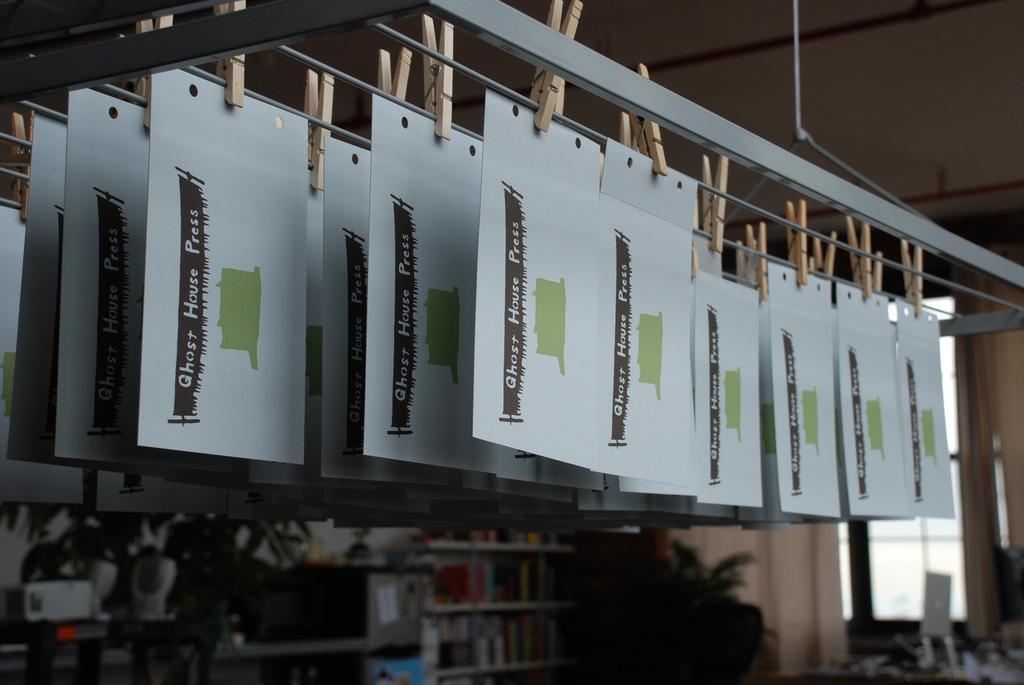In one or two sentences, can you explain what this image depicts? In this image there are few cards which are hanged to the poles by keeping the clips. On the cards there is some text. In the background there is a window. Beside the window it looks like there are racks on which there are books. 